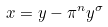<formula> <loc_0><loc_0><loc_500><loc_500>x = y - \pi ^ { n } y ^ { \sigma }</formula> 